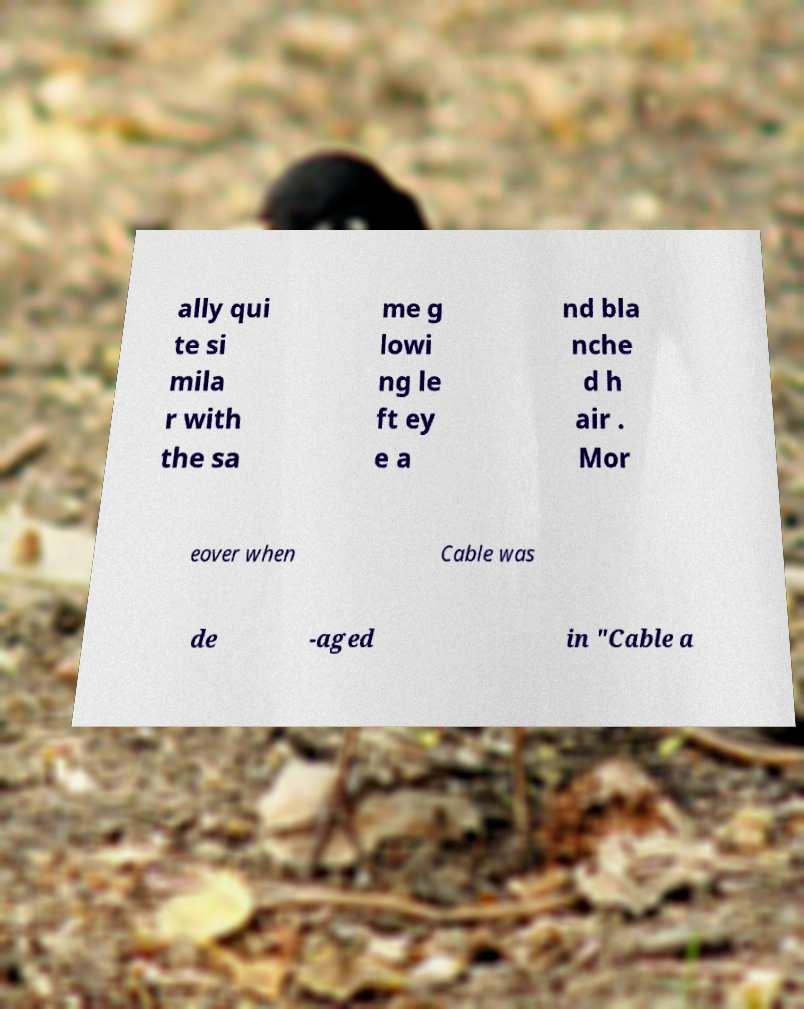Please read and relay the text visible in this image. What does it say? ally qui te si mila r with the sa me g lowi ng le ft ey e a nd bla nche d h air . Mor eover when Cable was de -aged in "Cable a 